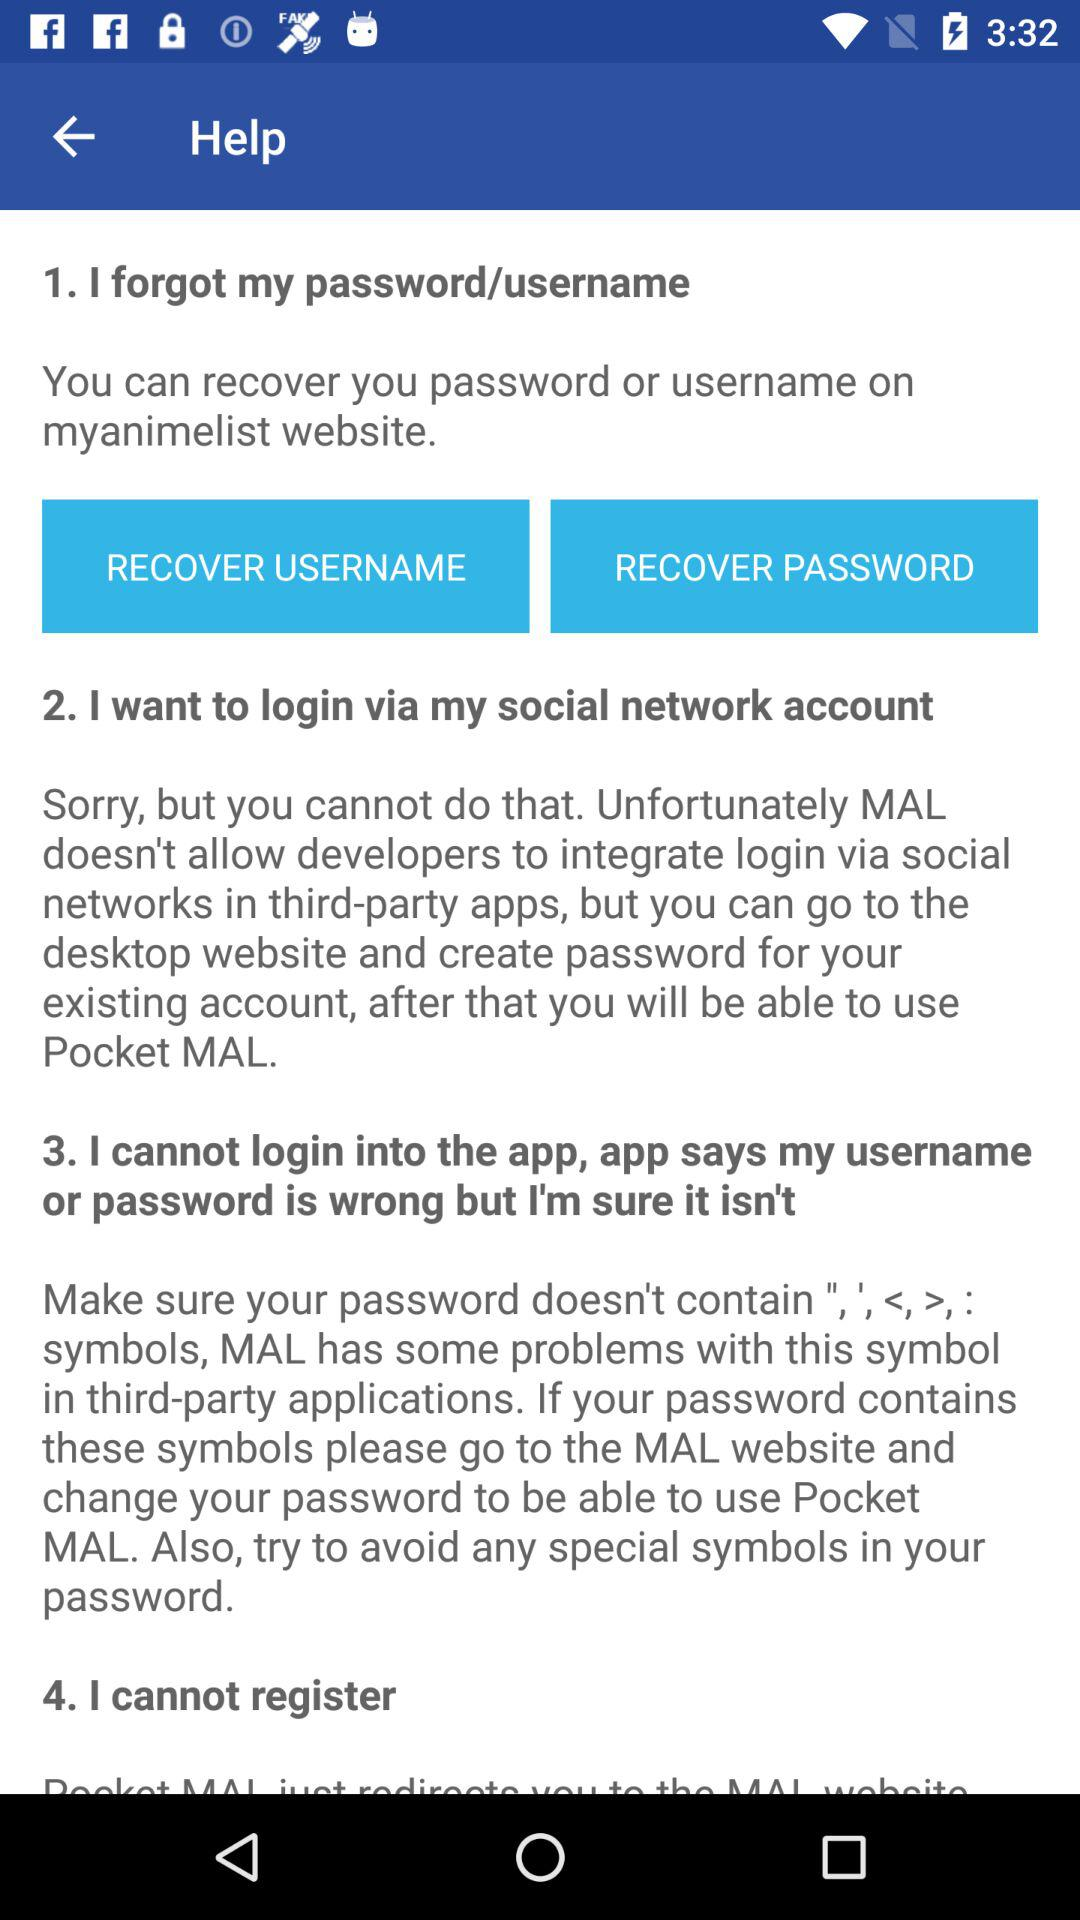How many sections are there in the help section?
Answer the question using a single word or phrase. 4 